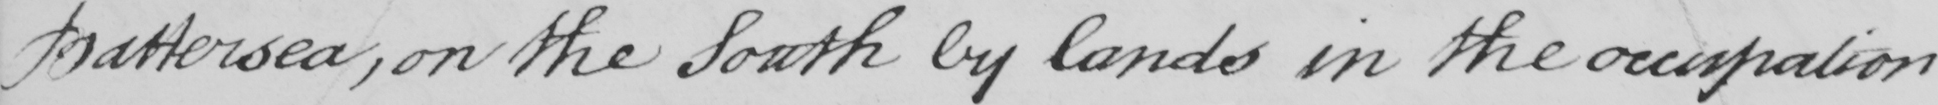Please transcribe the handwritten text in this image. Battersea , on the South by lands in the occupation 